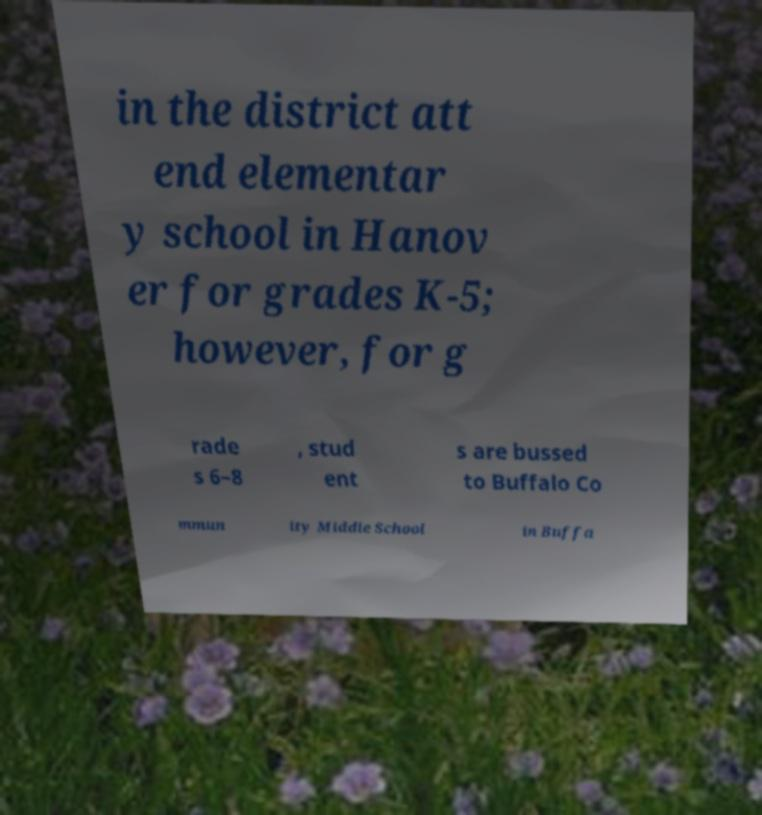Please identify and transcribe the text found in this image. in the district att end elementar y school in Hanov er for grades K-5; however, for g rade s 6–8 , stud ent s are bussed to Buffalo Co mmun ity Middle School in Buffa 